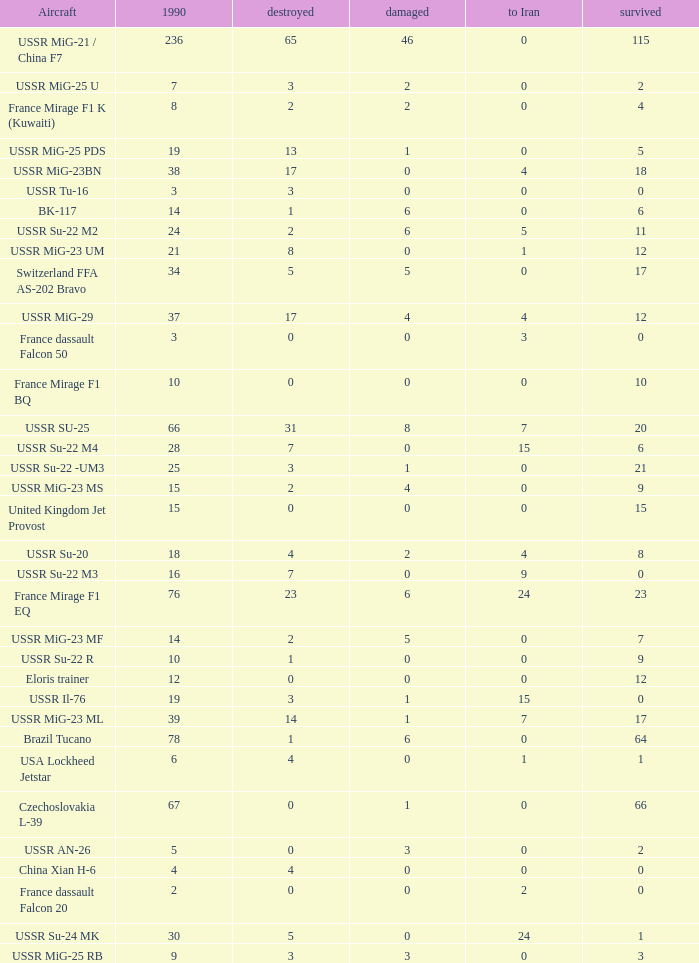If the aircraft was  ussr mig-25 rb how many were destroyed? 3.0. 